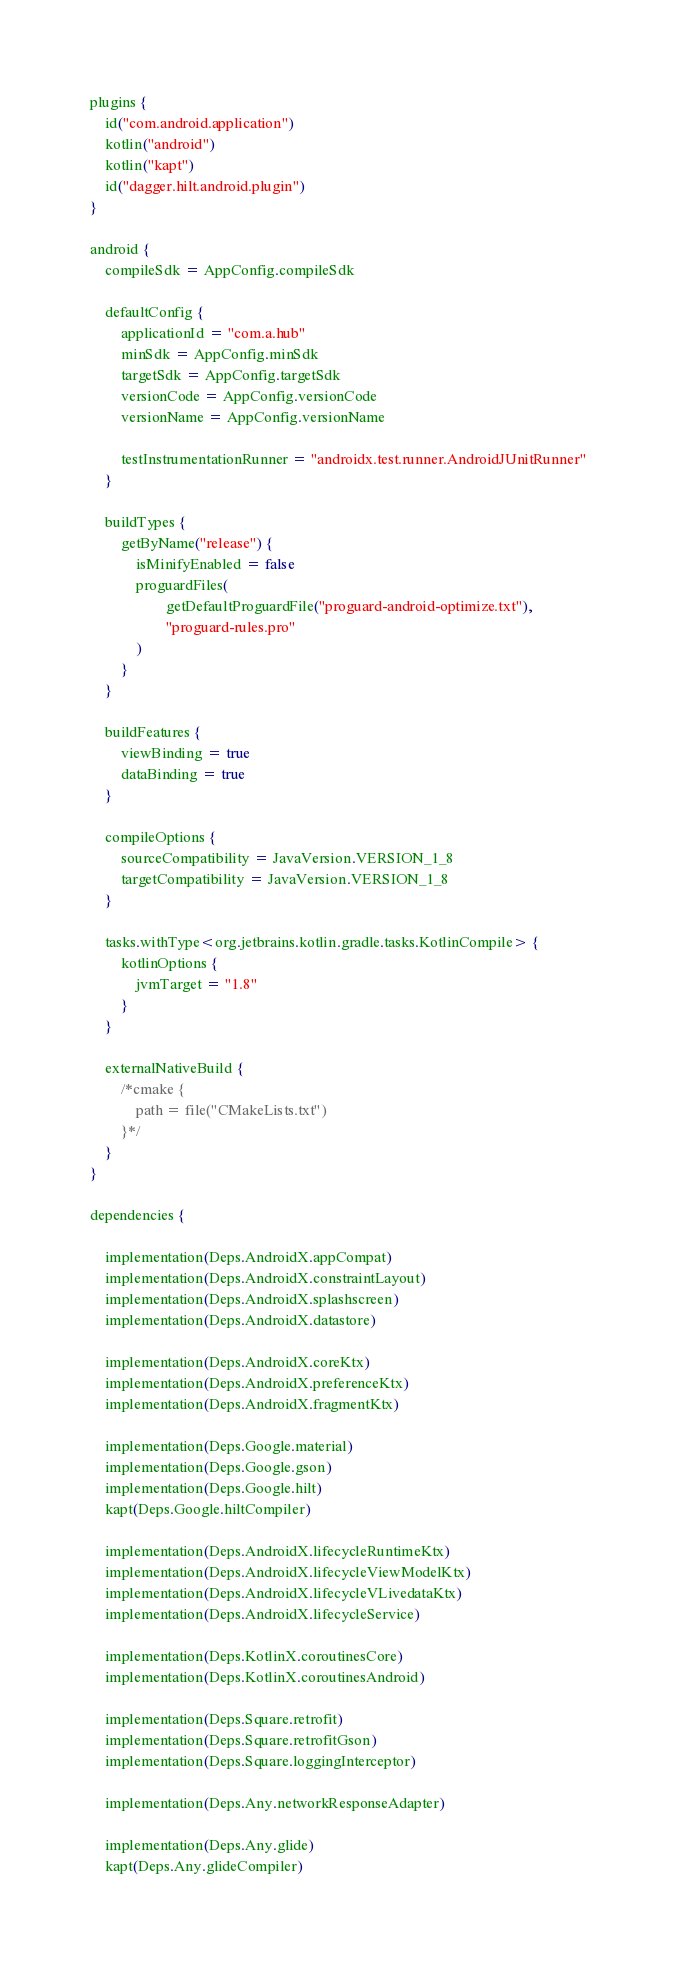Convert code to text. <code><loc_0><loc_0><loc_500><loc_500><_Kotlin_>plugins {
    id("com.android.application")
    kotlin("android")
    kotlin("kapt")
    id("dagger.hilt.android.plugin")
}

android {
    compileSdk = AppConfig.compileSdk

    defaultConfig {
        applicationId = "com.a.hub"
        minSdk = AppConfig.minSdk
        targetSdk = AppConfig.targetSdk
        versionCode = AppConfig.versionCode
        versionName = AppConfig.versionName

        testInstrumentationRunner = "androidx.test.runner.AndroidJUnitRunner"
    }

    buildTypes {
        getByName("release") {
            isMinifyEnabled = false
            proguardFiles(
                    getDefaultProguardFile("proguard-android-optimize.txt"),
                    "proguard-rules.pro"
            )
        }
    }

    buildFeatures {
        viewBinding = true
        dataBinding = true
    }

    compileOptions {
        sourceCompatibility = JavaVersion.VERSION_1_8
        targetCompatibility = JavaVersion.VERSION_1_8
    }

    tasks.withType<org.jetbrains.kotlin.gradle.tasks.KotlinCompile> {
        kotlinOptions {
            jvmTarget = "1.8"
        }
    }

    externalNativeBuild {
        /*cmake {
            path = file("CMakeLists.txt")
        }*/
    }
}

dependencies {

    implementation(Deps.AndroidX.appCompat)
    implementation(Deps.AndroidX.constraintLayout)
    implementation(Deps.AndroidX.splashscreen)
    implementation(Deps.AndroidX.datastore)

    implementation(Deps.AndroidX.coreKtx)
    implementation(Deps.AndroidX.preferenceKtx)
    implementation(Deps.AndroidX.fragmentKtx)

    implementation(Deps.Google.material)
    implementation(Deps.Google.gson)
    implementation(Deps.Google.hilt)
    kapt(Deps.Google.hiltCompiler)

    implementation(Deps.AndroidX.lifecycleRuntimeKtx)
    implementation(Deps.AndroidX.lifecycleViewModelKtx)
    implementation(Deps.AndroidX.lifecycleVLivedataKtx)
    implementation(Deps.AndroidX.lifecycleService)

    implementation(Deps.KotlinX.coroutinesCore)
    implementation(Deps.KotlinX.coroutinesAndroid)

    implementation(Deps.Square.retrofit)
    implementation(Deps.Square.retrofitGson)
    implementation(Deps.Square.loggingInterceptor)

    implementation(Deps.Any.networkResponseAdapter)

    implementation(Deps.Any.glide)
    kapt(Deps.Any.glideCompiler)
</code> 